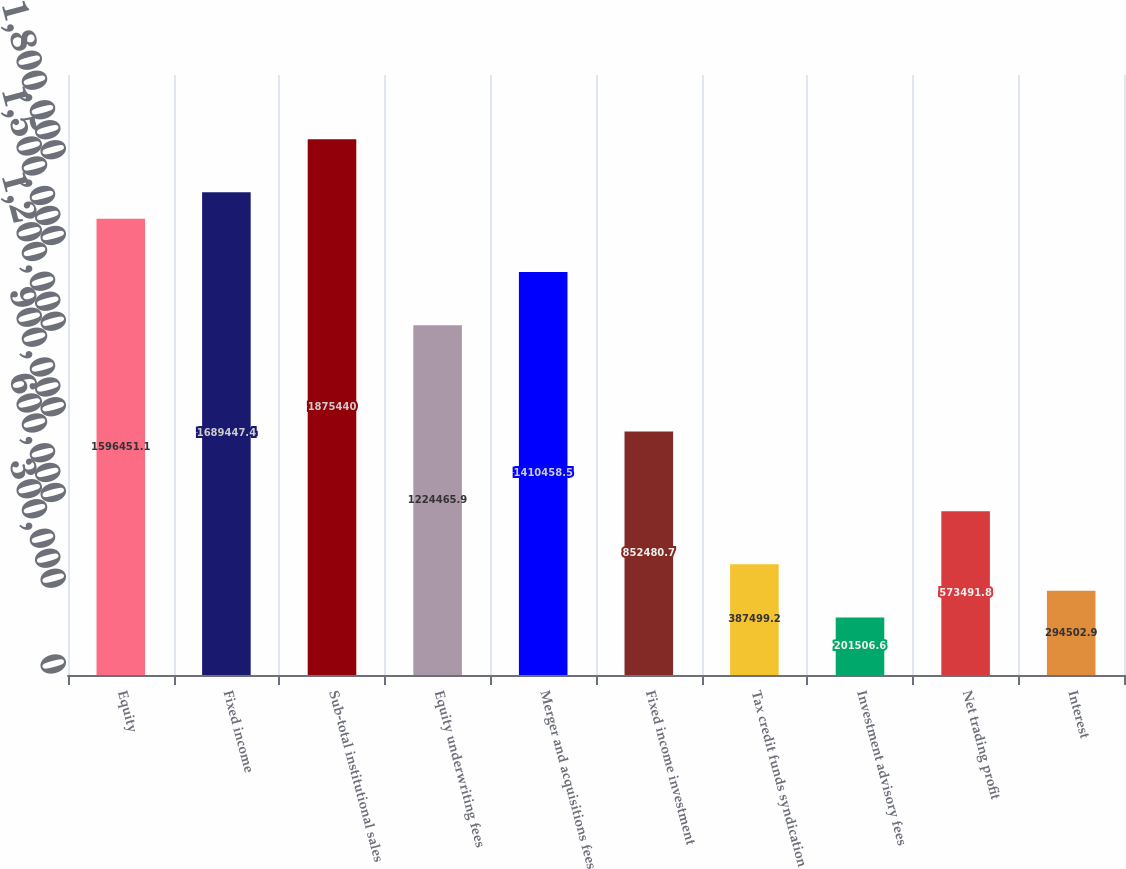Convert chart to OTSL. <chart><loc_0><loc_0><loc_500><loc_500><bar_chart><fcel>Equity<fcel>Fixed income<fcel>Sub-total institutional sales<fcel>Equity underwriting fees<fcel>Merger and acquisitions fees<fcel>Fixed income investment<fcel>Tax credit funds syndication<fcel>Investment advisory fees<fcel>Net trading profit<fcel>Interest<nl><fcel>1.59645e+06<fcel>1.68945e+06<fcel>1.87544e+06<fcel>1.22447e+06<fcel>1.41046e+06<fcel>852481<fcel>387499<fcel>201507<fcel>573492<fcel>294503<nl></chart> 